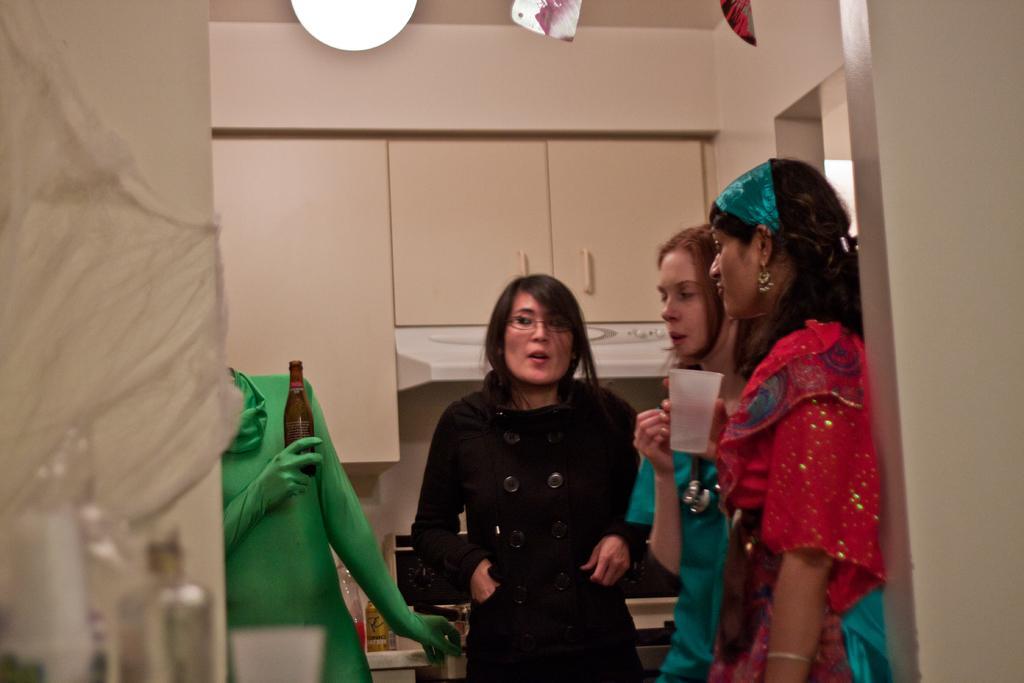Describe this image in one or two sentences. In the center we can see few persons were standing and holding glass and wine bottle. And back there is a wall,cupboard,light and few more objects. 